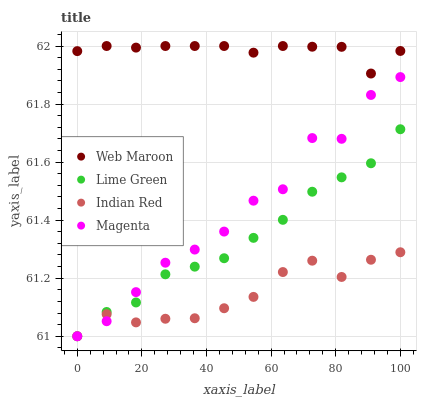Does Indian Red have the minimum area under the curve?
Answer yes or no. Yes. Does Web Maroon have the maximum area under the curve?
Answer yes or no. Yes. Does Magenta have the minimum area under the curve?
Answer yes or no. No. Does Magenta have the maximum area under the curve?
Answer yes or no. No. Is Lime Green the smoothest?
Answer yes or no. Yes. Is Magenta the roughest?
Answer yes or no. Yes. Is Web Maroon the smoothest?
Answer yes or no. No. Is Web Maroon the roughest?
Answer yes or no. No. Does Lime Green have the lowest value?
Answer yes or no. Yes. Does Web Maroon have the lowest value?
Answer yes or no. No. Does Web Maroon have the highest value?
Answer yes or no. Yes. Does Magenta have the highest value?
Answer yes or no. No. Is Lime Green less than Web Maroon?
Answer yes or no. Yes. Is Web Maroon greater than Magenta?
Answer yes or no. Yes. Does Magenta intersect Indian Red?
Answer yes or no. Yes. Is Magenta less than Indian Red?
Answer yes or no. No. Is Magenta greater than Indian Red?
Answer yes or no. No. Does Lime Green intersect Web Maroon?
Answer yes or no. No. 